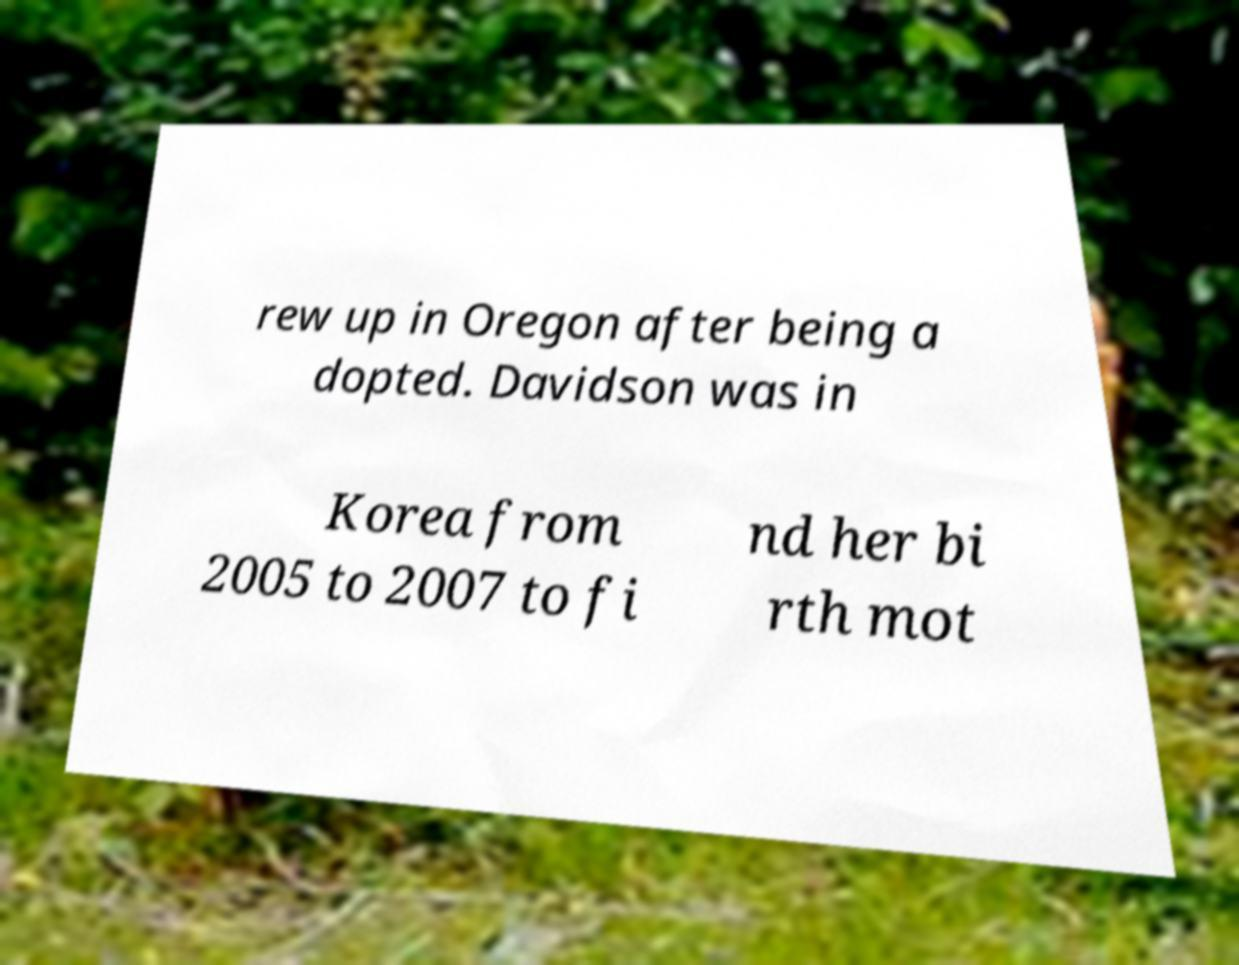Please identify and transcribe the text found in this image. rew up in Oregon after being a dopted. Davidson was in Korea from 2005 to 2007 to fi nd her bi rth mot 